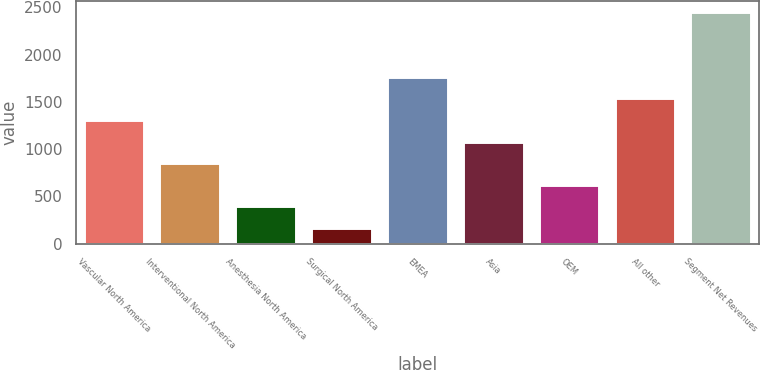<chart> <loc_0><loc_0><loc_500><loc_500><bar_chart><fcel>Vascular North America<fcel>Interventional North America<fcel>Anesthesia North America<fcel>Surgical North America<fcel>EMEA<fcel>Asia<fcel>OEM<fcel>All other<fcel>Segment Net Revenues<nl><fcel>1307.35<fcel>850.93<fcel>394.51<fcel>166.3<fcel>1763.77<fcel>1079.14<fcel>622.72<fcel>1535.56<fcel>2448.4<nl></chart> 